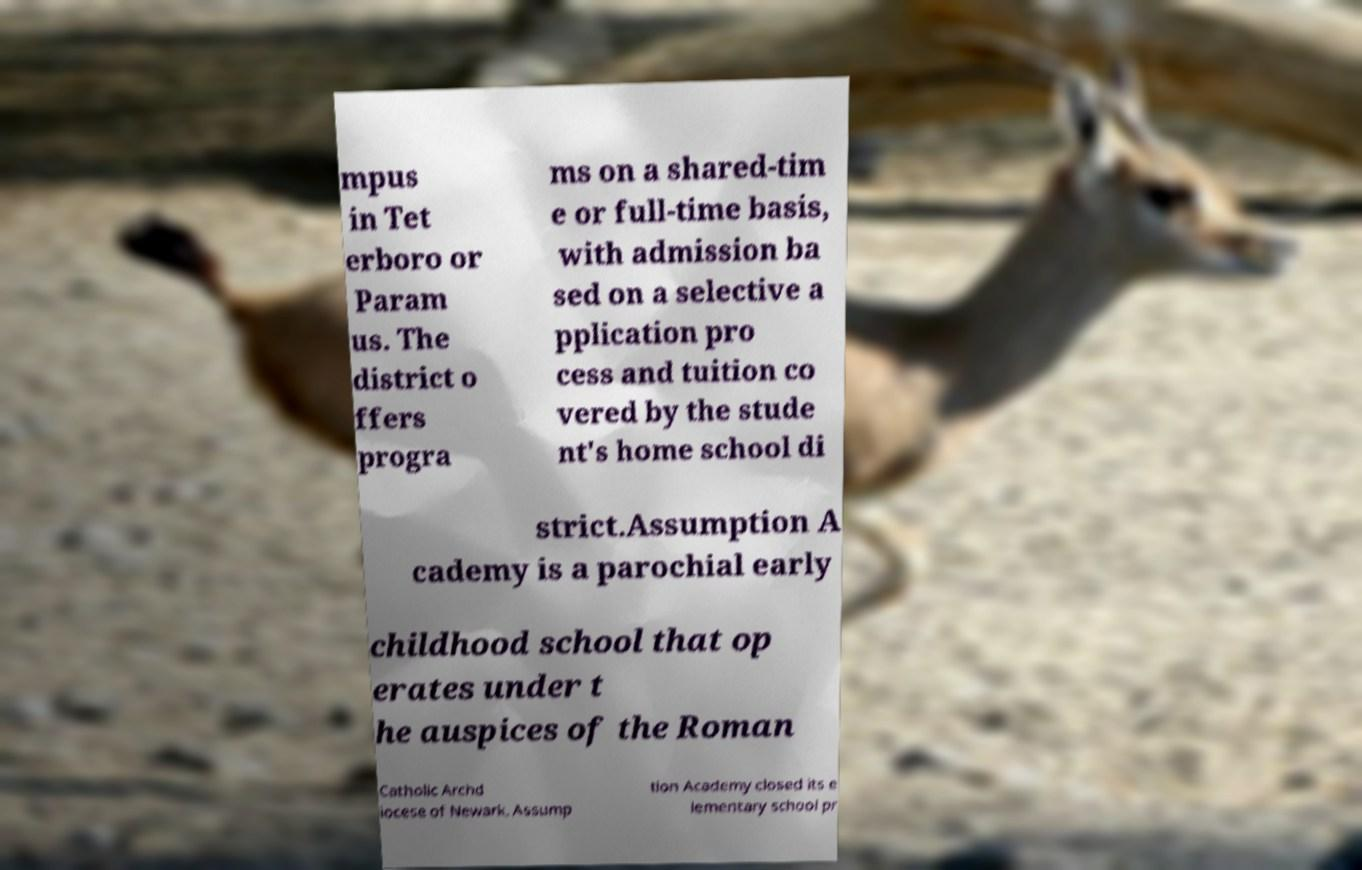There's text embedded in this image that I need extracted. Can you transcribe it verbatim? mpus in Tet erboro or Param us. The district o ffers progra ms on a shared-tim e or full-time basis, with admission ba sed on a selective a pplication pro cess and tuition co vered by the stude nt's home school di strict.Assumption A cademy is a parochial early childhood school that op erates under t he auspices of the Roman Catholic Archd iocese of Newark. Assump tion Academy closed its e lementary school pr 